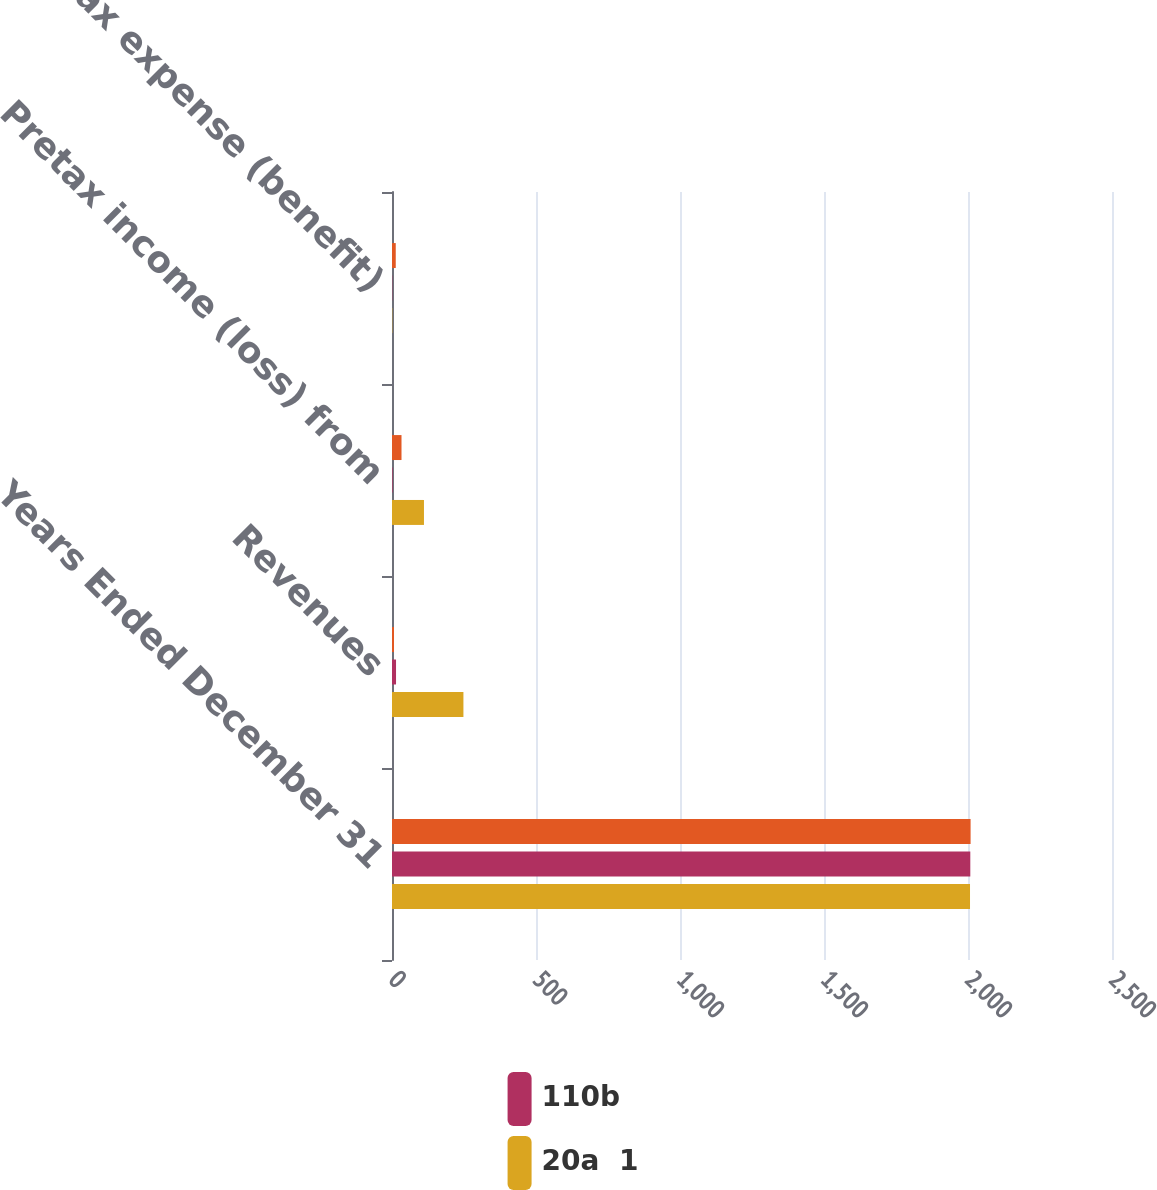Convert chart to OTSL. <chart><loc_0><loc_0><loc_500><loc_500><stacked_bar_chart><ecel><fcel>Years Ended December 31<fcel>Revenues<fcel>Pretax income (loss) from<fcel>Income tax expense (benefit)<nl><fcel>nan<fcel>2009<fcel>7<fcel>33<fcel>13<nl><fcel>110b<fcel>2008<fcel>14<fcel>2<fcel>1<nl><fcel>20a  1<fcel>2007<fcel>248<fcel>111<fcel>1<nl></chart> 